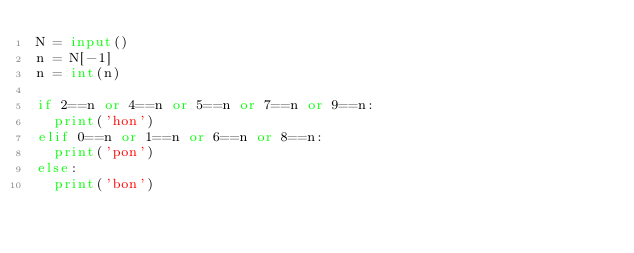<code> <loc_0><loc_0><loc_500><loc_500><_Python_>N = input()
n = N[-1]
n = int(n)

if 2==n or 4==n or 5==n or 7==n or 9==n:
  print('hon')
elif 0==n or 1==n or 6==n or 8==n:
  print('pon')
else:
  print('bon')</code> 